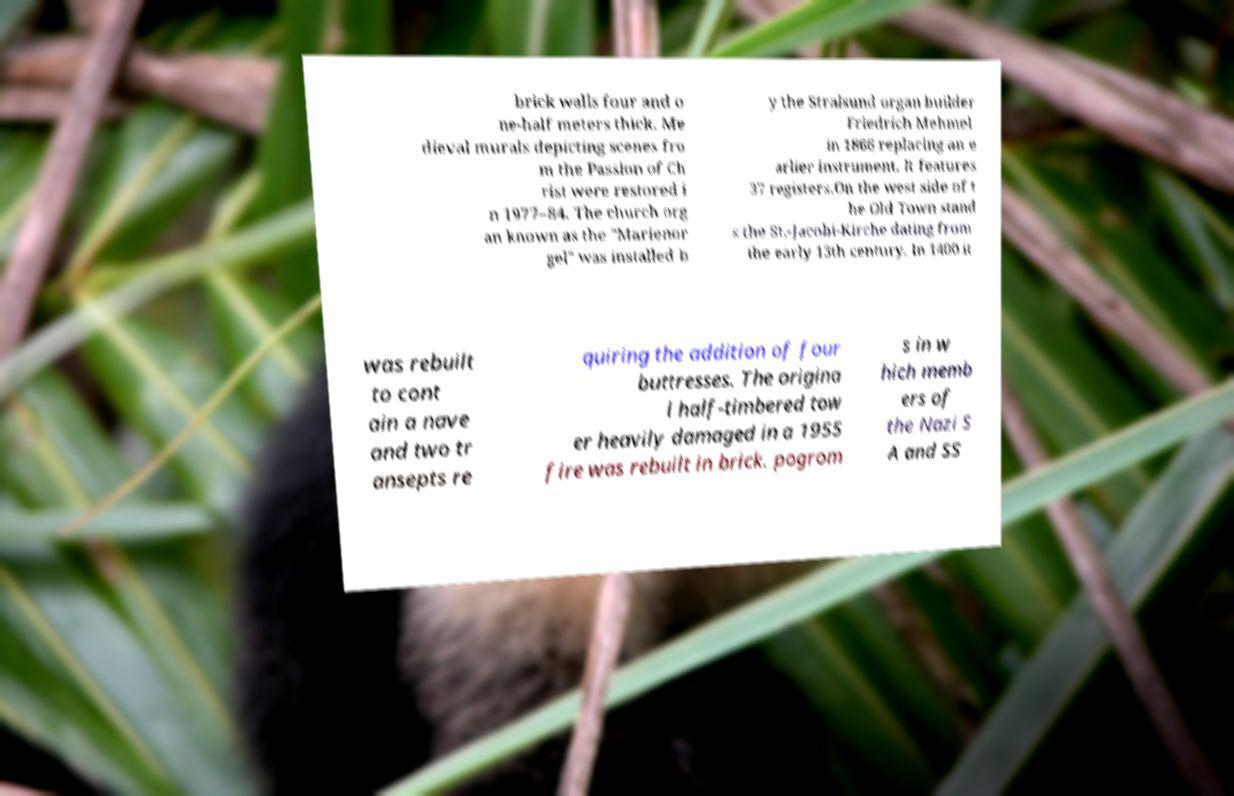Can you accurately transcribe the text from the provided image for me? brick walls four and o ne-half meters thick. Me dieval murals depicting scenes fro m the Passion of Ch rist were restored i n 1977–84. The church org an known as the "Marienor gel" was installed b y the Stralsund organ builder Friedrich Mehmel in 1866 replacing an e arlier instrument. It features 37 registers.On the west side of t he Old Town stand s the St.-Jacobi-Kirche dating from the early 13th century. In 1400 it was rebuilt to cont ain a nave and two tr ansepts re quiring the addition of four buttresses. The origina l half-timbered tow er heavily damaged in a 1955 fire was rebuilt in brick. pogrom s in w hich memb ers of the Nazi S A and SS 